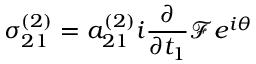<formula> <loc_0><loc_0><loc_500><loc_500>\sigma _ { 2 1 } ^ { ( 2 ) } = a _ { 2 1 } ^ { ( 2 ) } i \frac { \partial } { \partial t _ { 1 } } \mathcal { F } e ^ { i \theta }</formula> 